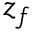Convert formula to latex. <formula><loc_0><loc_0><loc_500><loc_500>z _ { f }</formula> 